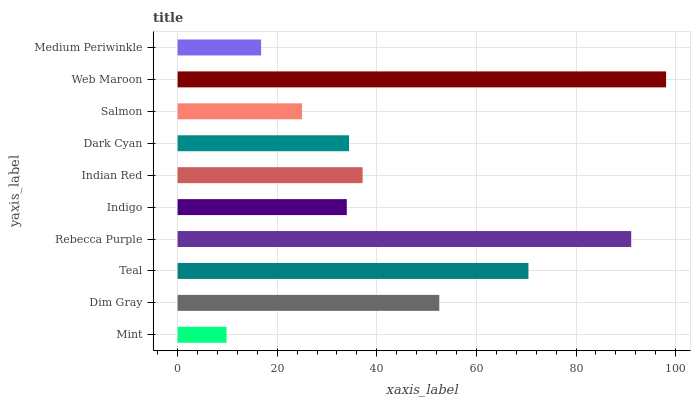Is Mint the minimum?
Answer yes or no. Yes. Is Web Maroon the maximum?
Answer yes or no. Yes. Is Dim Gray the minimum?
Answer yes or no. No. Is Dim Gray the maximum?
Answer yes or no. No. Is Dim Gray greater than Mint?
Answer yes or no. Yes. Is Mint less than Dim Gray?
Answer yes or no. Yes. Is Mint greater than Dim Gray?
Answer yes or no. No. Is Dim Gray less than Mint?
Answer yes or no. No. Is Indian Red the high median?
Answer yes or no. Yes. Is Dark Cyan the low median?
Answer yes or no. Yes. Is Dark Cyan the high median?
Answer yes or no. No. Is Dim Gray the low median?
Answer yes or no. No. 